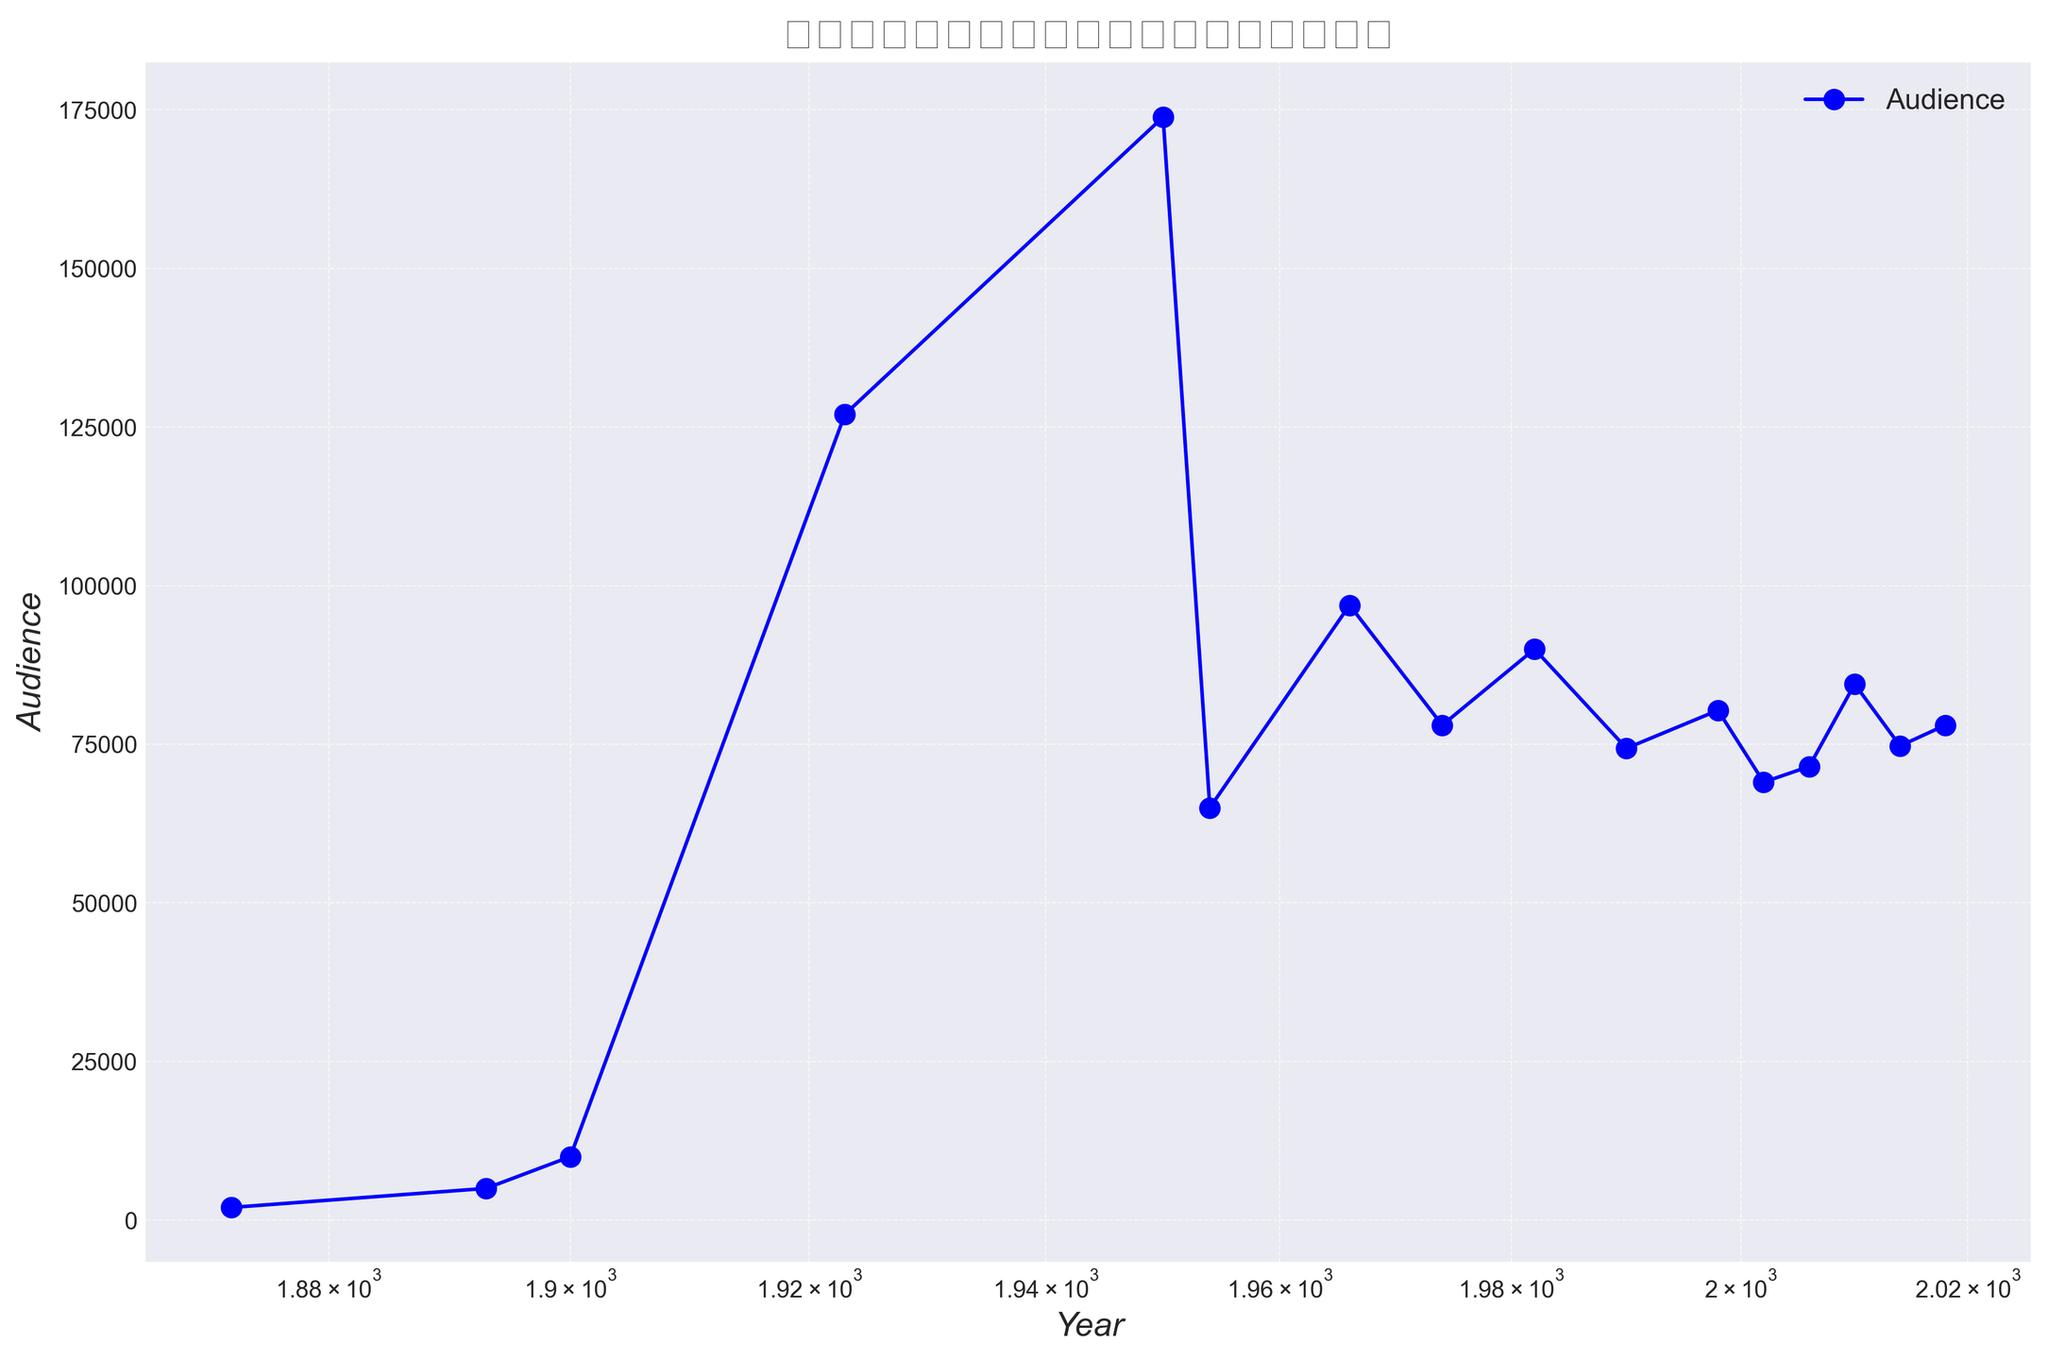What is the trend of audience numbers over the years? Observing the line plot, we see a generally increasing trend in the number of audience members from 1872 to around 1950, followed by fluctuations and a more stable trend. Significant spikes are visible in specific years such as 1923 and 1950.
Answer: Increasing with fluctuations In which year did the audience reach the highest number, and what was that number? The highest number of audiences is observed in 1950, with a value of 173850.
Answer: 1950, 173850 By how much did the audience number increase from 1893 (5000) to 1900 (10000)? To find the increase, subtract the audience number in 1893 from that in 1900: 10000 - 5000 = 5000.
Answer: 5000 What is the difference in audience numbers between the years 1966 (96924) and 1974 (78011)? Subtract the audience number in 1974 from that in 1966: 96924 - 78011 = 18913.
Answer: 18913 How has the audience number changed from the earliest year (1872) to the latest year (2018)? The number increased from 2000 in 1872 to 78011 in 2018. Subtract the earliest year's audience number from the latest year's number: 78011 - 2000 = 76011.
Answer: 76011 From the years listed, what are the three years with the lowest audience numbers? The three years with the lowest numbers are 1872 (2000), 1893 (5000), and 1900 (10000).
Answer: 1872, 1893, 1900 Compare the audience numbers in 1982 (90000) and 2006 (71500). Which year had a higher attendance, and by how much? 1982 had higher attendance. Subtract the 2006 figure from the 1982 figure: 90000 - 71500 = 18500.
Answer: 1982, 18500 Which year corresponds to the significant spike in audience numbers visible on the plot, and what was the value? The significant spike is seen in the year 1950 with an audience number of 173850.
Answer: 1950, 173850 What is the average audience number for the years 2010 (84490), 2014 (74738), and 2018 (78011)? Add the audience numbers and divide by 3: (84490 + 74738 + 78011)/3 = 79079.67.
Answer: 79079.67 What can you infer about the trend of audience numbers after the spike in 1950? After 1950, the audience numbers show fluctuations without returning to the spike level, indicating a more variable but roughly stable trend.
Answer: Fluctuates but stable 